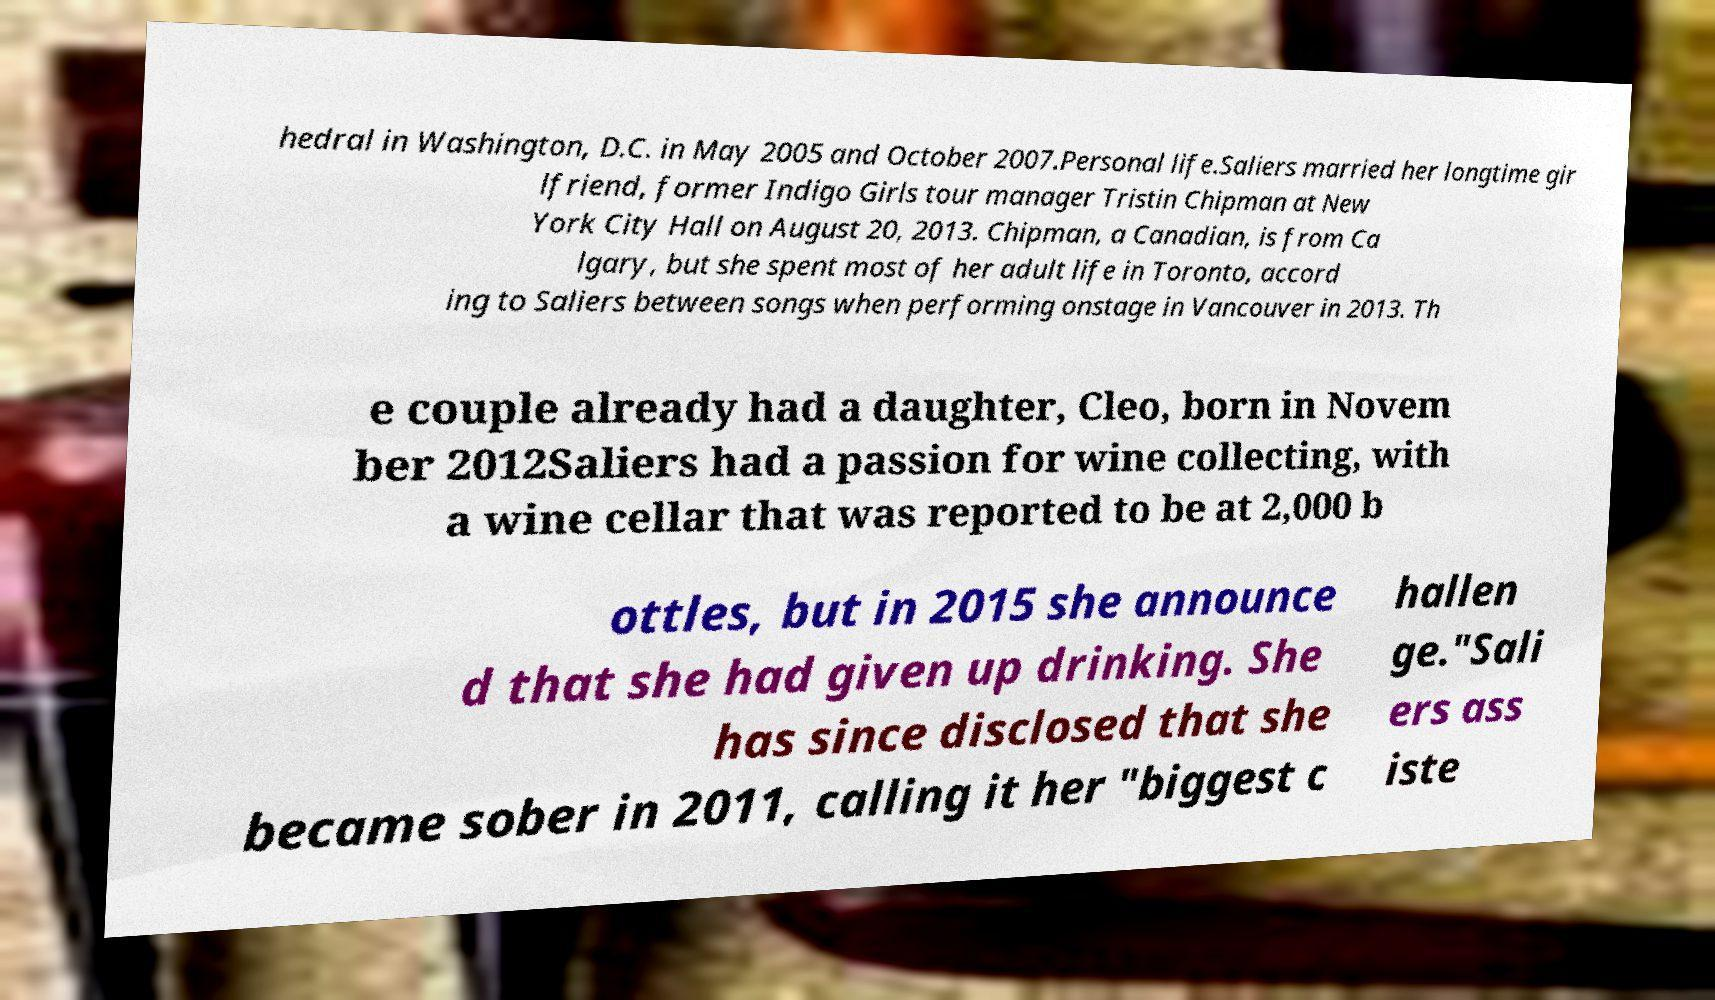What messages or text are displayed in this image? I need them in a readable, typed format. hedral in Washington, D.C. in May 2005 and October 2007.Personal life.Saliers married her longtime gir lfriend, former Indigo Girls tour manager Tristin Chipman at New York City Hall on August 20, 2013. Chipman, a Canadian, is from Ca lgary, but she spent most of her adult life in Toronto, accord ing to Saliers between songs when performing onstage in Vancouver in 2013. Th e couple already had a daughter, Cleo, born in Novem ber 2012Saliers had a passion for wine collecting, with a wine cellar that was reported to be at 2,000 b ottles, but in 2015 she announce d that she had given up drinking. She has since disclosed that she became sober in 2011, calling it her "biggest c hallen ge."Sali ers ass iste 